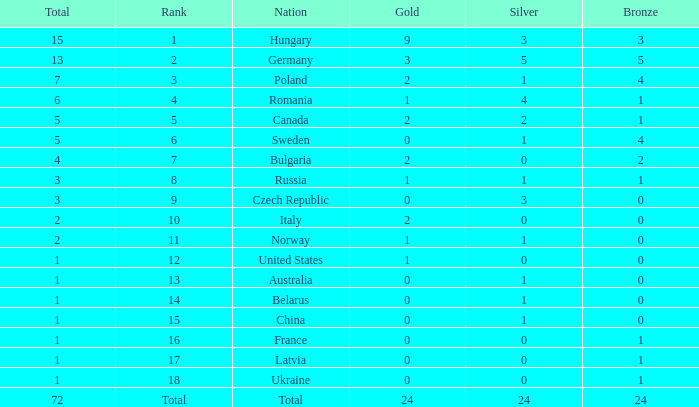What average silver has belarus as the nation, with a total less than 1? None. 